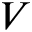Convert formula to latex. <formula><loc_0><loc_0><loc_500><loc_500>V</formula> 